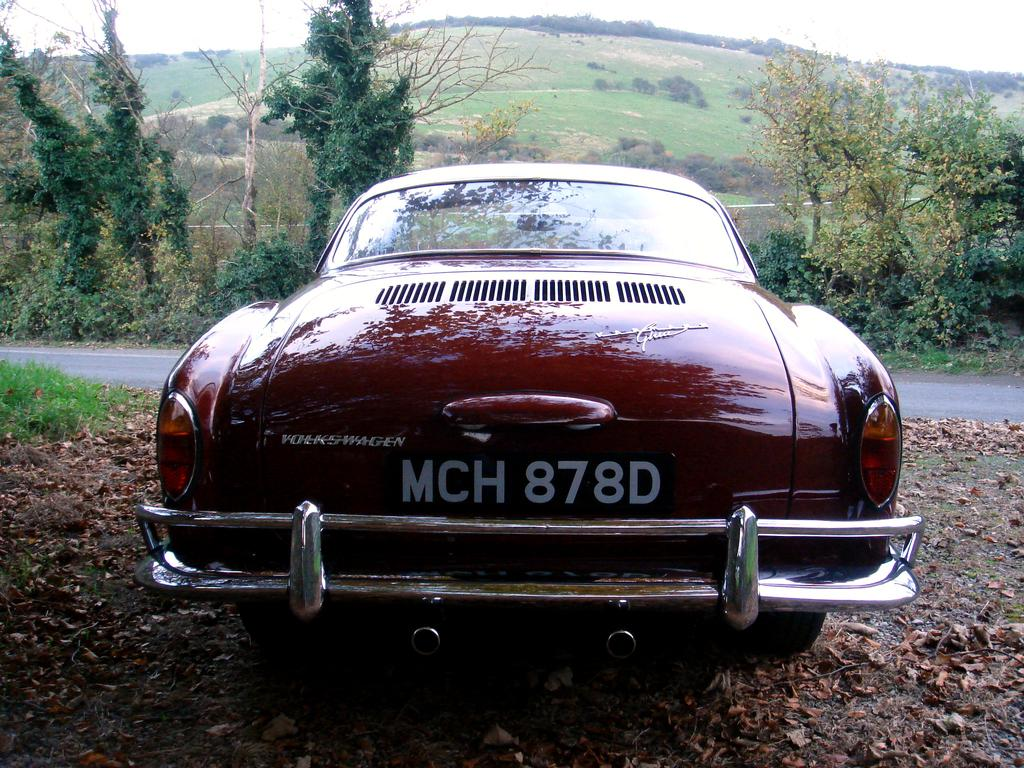What color is the car in the image? The car in the image is red. What type of vegetation can be seen in the image? Leaves and grass are visible in the image. What type of pathway is present in the image? There is a road in the image. What can be seen in the background of the image? Trees, plants, a hill, and the sky are visible in the background of the image. What type of chairs can be seen in the image? There are no chairs present in the image. What does the voice of the man in the image sound like? There is no man or voice present in the image. 